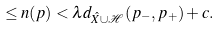Convert formula to latex. <formula><loc_0><loc_0><loc_500><loc_500>\leq n ( p ) < \lambda d _ { \hat { X } \cup \mathcal { H } } ( p _ { - } , p _ { + } ) + c .</formula> 